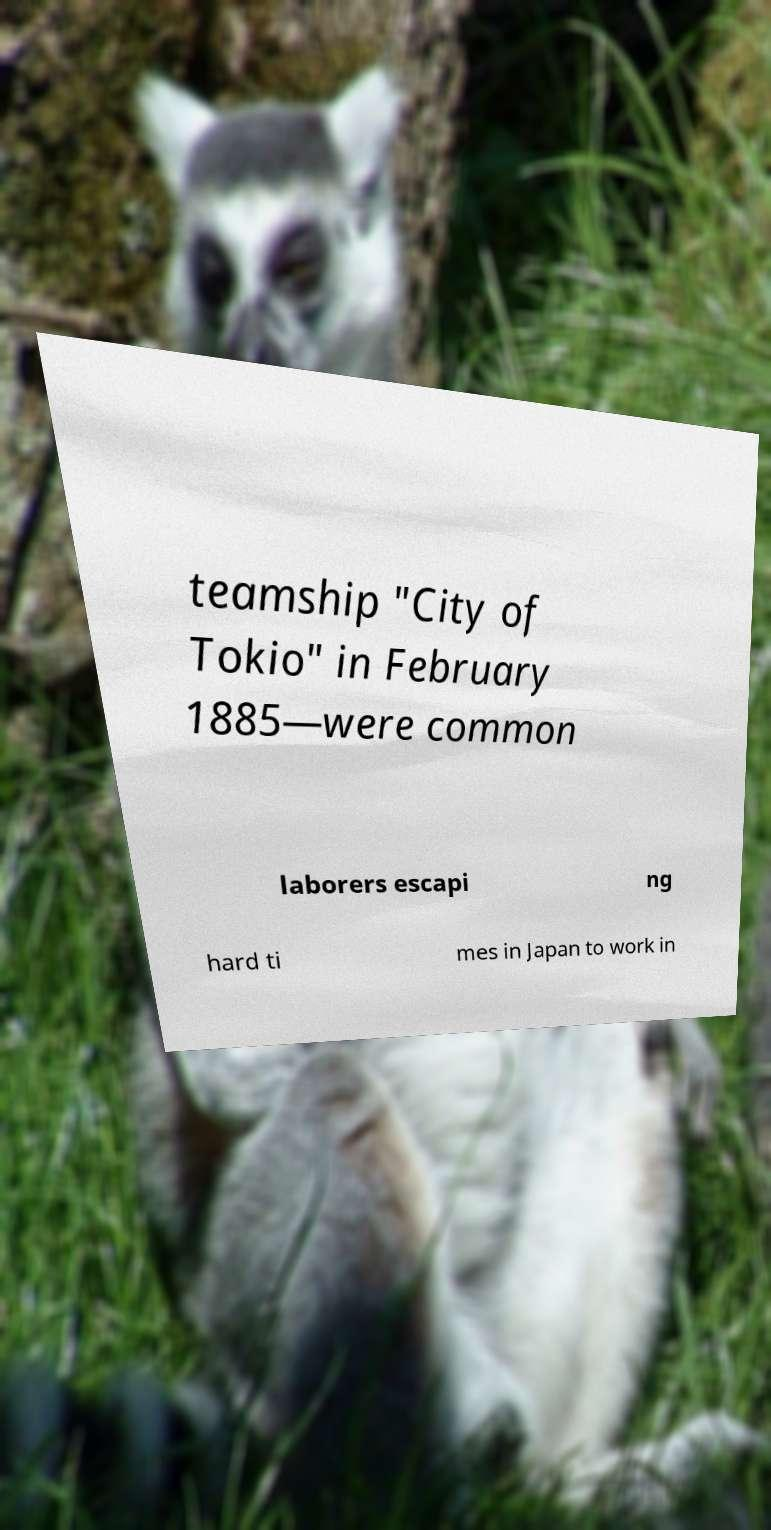Please identify and transcribe the text found in this image. teamship "City of Tokio" in February 1885—were common laborers escapi ng hard ti mes in Japan to work in 